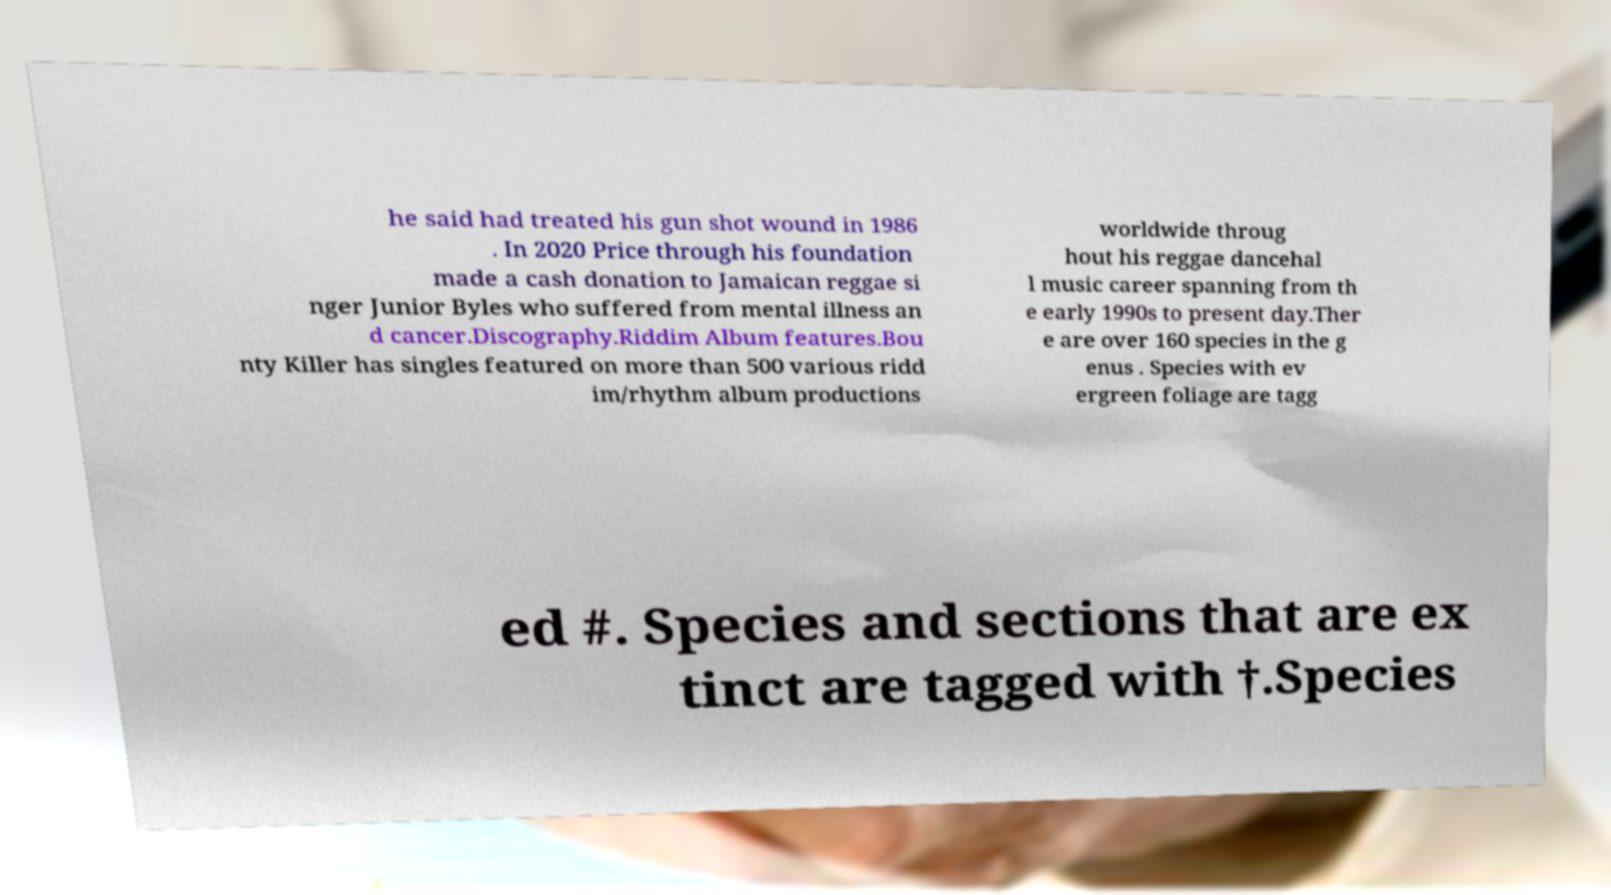Please identify and transcribe the text found in this image. he said had treated his gun shot wound in 1986 . In 2020 Price through his foundation made a cash donation to Jamaican reggae si nger Junior Byles who suffered from mental illness an d cancer.Discography.Riddim Album features.Bou nty Killer has singles featured on more than 500 various ridd im/rhythm album productions worldwide throug hout his reggae dancehal l music career spanning from th e early 1990s to present day.Ther e are over 160 species in the g enus . Species with ev ergreen foliage are tagg ed #. Species and sections that are ex tinct are tagged with †.Species 